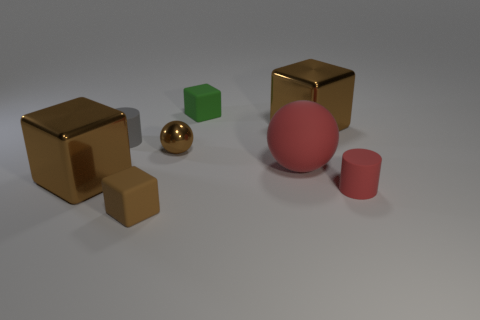There is a small cube that is the same color as the metallic ball; what material is it?
Provide a succinct answer. Rubber. The big metallic thing that is left of the small cube behind the large red sphere is what shape?
Your answer should be very brief. Cube. How many tiny red cylinders have the same material as the big red ball?
Your answer should be compact. 1. What color is the large ball that is made of the same material as the green cube?
Make the answer very short. Red. What is the size of the brown block behind the big metallic cube to the left of the large brown metallic object right of the tiny metal ball?
Offer a very short reply. Large. Are there fewer metallic things than small balls?
Make the answer very short. No. What color is the rubber thing that is the same shape as the small brown shiny thing?
Give a very brief answer. Red. There is a small brown cube that is in front of the large metallic thing to the right of the small sphere; are there any shiny objects on the right side of it?
Offer a terse response. Yes. Do the small brown rubber thing and the small green thing have the same shape?
Keep it short and to the point. Yes. Are there fewer large red matte spheres to the left of the tiny brown matte thing than small yellow metallic cylinders?
Ensure brevity in your answer.  No. 